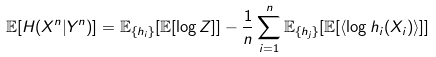Convert formula to latex. <formula><loc_0><loc_0><loc_500><loc_500>\mathbb { E } [ H ( X ^ { n } | Y ^ { n } ) ] = \mathbb { E } _ { \{ h _ { i } \} } [ \mathbb { E } [ \log Z ] ] - \frac { 1 } { n } \sum _ { i = 1 } ^ { n } \mathbb { E } _ { \{ h _ { j } \} } [ \mathbb { E } [ \langle \log h _ { i } ( X _ { i } ) \rangle ] ]</formula> 